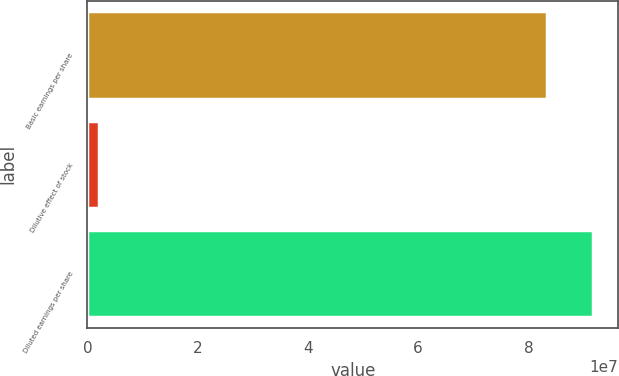<chart> <loc_0><loc_0><loc_500><loc_500><bar_chart><fcel>Basic earnings per share<fcel>Dilutive effect of stock<fcel>Diluted earnings per share<nl><fcel>8.33469e+07<fcel>2.05882e+06<fcel>9.16816e+07<nl></chart> 